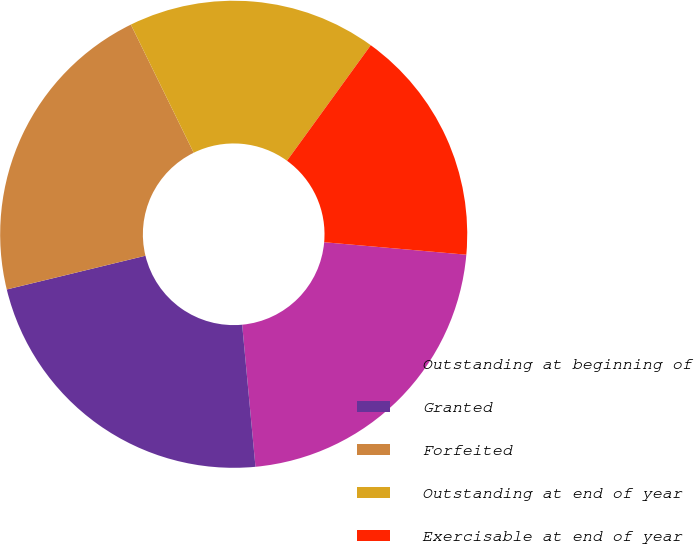<chart> <loc_0><loc_0><loc_500><loc_500><pie_chart><fcel>Outstanding at beginning of<fcel>Granted<fcel>Forfeited<fcel>Outstanding at end of year<fcel>Exercisable at end of year<nl><fcel>22.12%<fcel>22.69%<fcel>21.54%<fcel>17.24%<fcel>16.41%<nl></chart> 